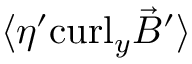Convert formula to latex. <formula><loc_0><loc_0><loc_500><loc_500>\langle \eta ^ { \prime } c u r l _ { y } { \vec { B } } ^ { \prime } \rangle</formula> 